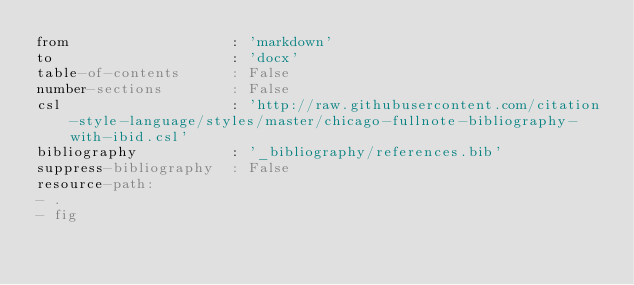<code> <loc_0><loc_0><loc_500><loc_500><_YAML_>from                   : 'markdown'
to                     : 'docx'
table-of-contents      : False
number-sections        : False
csl                    : 'http://raw.githubusercontent.com/citation-style-language/styles/master/chicago-fullnote-bibliography-with-ibid.csl'
bibliography           : '_bibliography/references.bib'
suppress-bibliography  : False
resource-path:
- .
- fig
</code> 